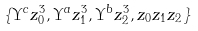Convert formula to latex. <formula><loc_0><loc_0><loc_500><loc_500>\{ \Upsilon ^ { c } z _ { 0 } ^ { 3 } , \Upsilon ^ { a } z _ { 1 } ^ { 3 } , \Upsilon ^ { b } z _ { 2 } ^ { 3 } , z _ { 0 } z _ { 1 } z _ { 2 } \}</formula> 